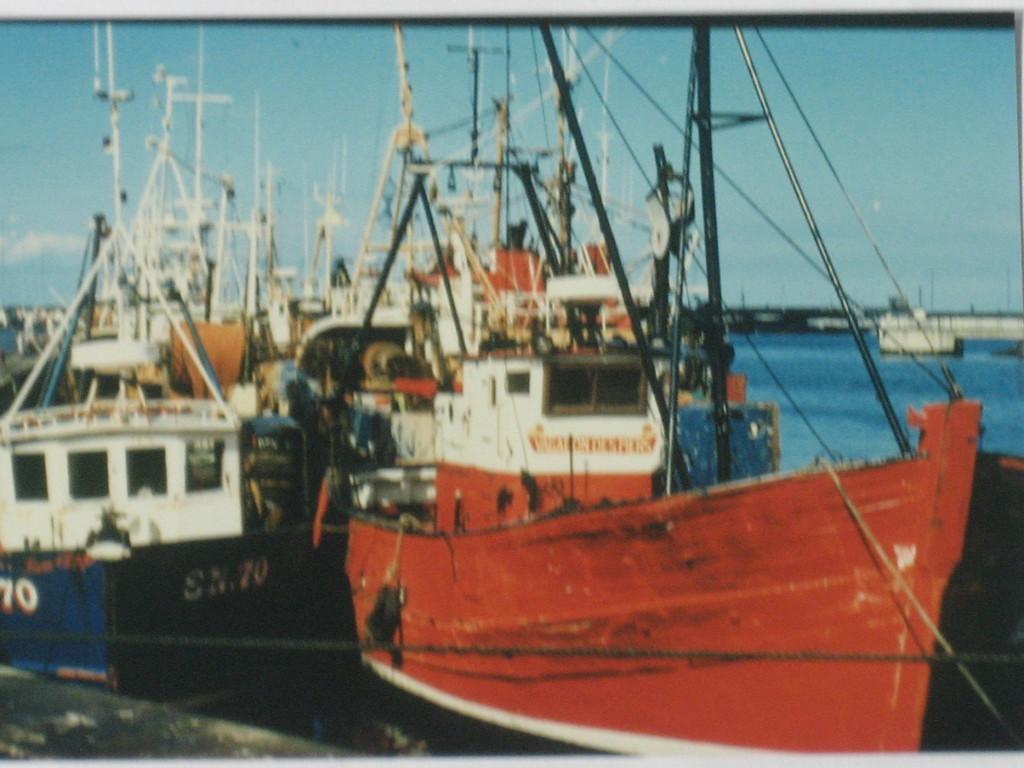What's the hull number of this boat?
Offer a terse response. 70. What is the letters on the blue boat?
Make the answer very short. Sn. 